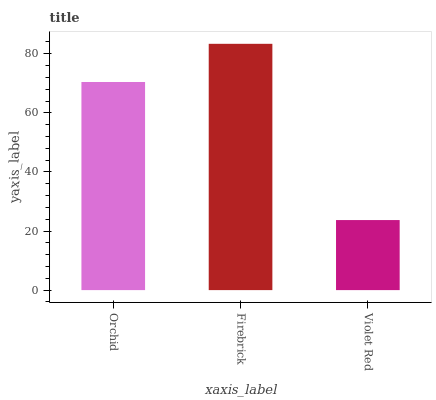Is Firebrick the minimum?
Answer yes or no. No. Is Violet Red the maximum?
Answer yes or no. No. Is Firebrick greater than Violet Red?
Answer yes or no. Yes. Is Violet Red less than Firebrick?
Answer yes or no. Yes. Is Violet Red greater than Firebrick?
Answer yes or no. No. Is Firebrick less than Violet Red?
Answer yes or no. No. Is Orchid the high median?
Answer yes or no. Yes. Is Orchid the low median?
Answer yes or no. Yes. Is Violet Red the high median?
Answer yes or no. No. Is Firebrick the low median?
Answer yes or no. No. 